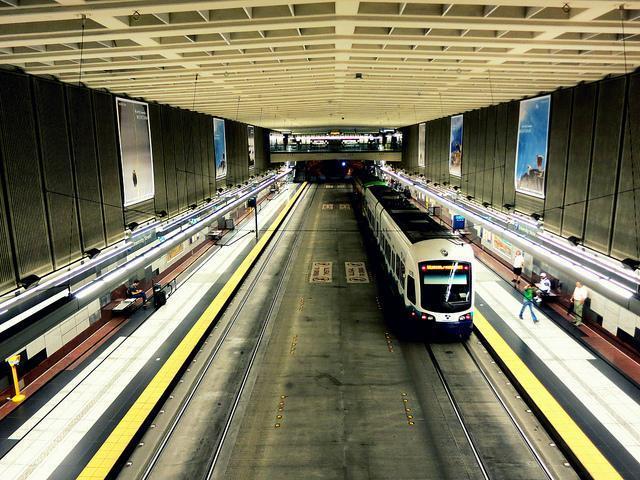How many trains are there?
Give a very brief answer. 1. How many trains can be seen?
Give a very brief answer. 2. How many zebras are standing in this image ?
Give a very brief answer. 0. 